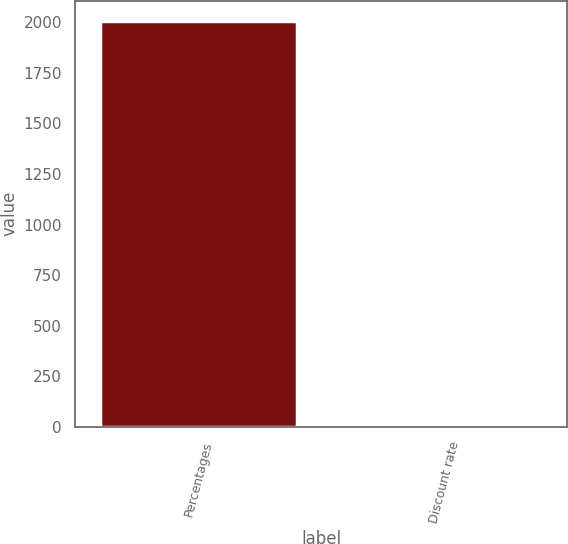Convert chart to OTSL. <chart><loc_0><loc_0><loc_500><loc_500><bar_chart><fcel>Percentages<fcel>Discount rate<nl><fcel>2007<fcel>6<nl></chart> 